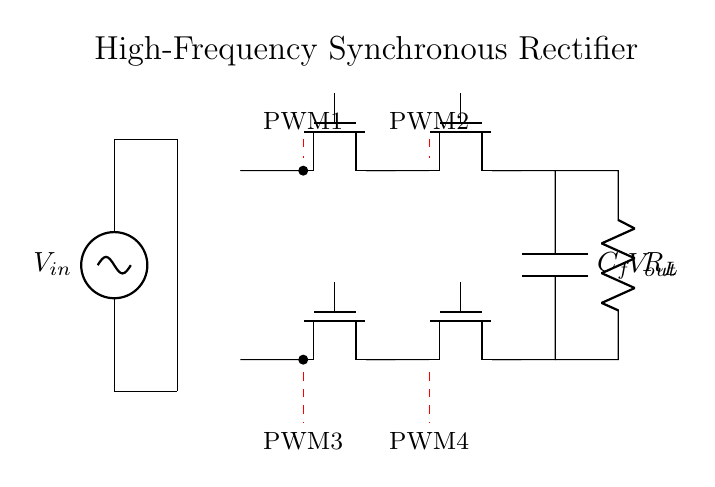What is the input voltage in this circuit? The input voltage is labeled as V_in in the circuit diagram, which directly indicates the voltage applied to the system.
Answer: V_in How many MOSFETs are used in the rectifier? The circuit diagram shows four MOSFETs labeled M1, M2, M3, and M4, confirming their presence and role in the rectification process.
Answer: 4 What is the function of capacitor C_f in this circuit? Capacitor C_f is connected in parallel with the load resistor R_L and serves to smooth out the output voltage by filtering high-frequency ripples from the rectified output.
Answer: Filter What are the control signals indicated in the circuit? The circuit diagram features control signals labeled as PWM1, PWM2, PWM3, and PWM4, which are used to regulate the switching operations of the MOSFETs for efficient rectification.
Answer: PWM1, PWM2, PWM3, PWM4 What type of rectifier configuration is used in this circuit? The arrangement of the MOSFETs and the presence of the transformer specifically indicate that this is a synchronous rectifier configuration, which is designed for improved efficiency compared to traditional diode rectifiers.
Answer: Synchronous How does the output voltage relate to the PWM signals? The output voltage is regulated by the duty cycles of the PWM signals PWM1 and PWM2 which control the MOSFETs M1 and M3, affecting the conduction states and ultimately the amount of output voltage produced across R_L.
Answer: Duty cycle Why is a transformer included in this circuit? The transformer is included to step up or step down the input voltage level, ensuring that the system can operate efficiently at different voltage levels as required by the telecommunications application.
Answer: Voltage conversion 